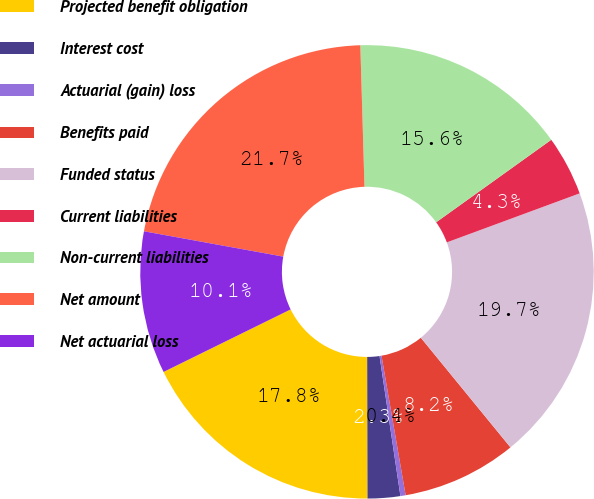Convert chart. <chart><loc_0><loc_0><loc_500><loc_500><pie_chart><fcel>Projected benefit obligation<fcel>Interest cost<fcel>Actuarial (gain) loss<fcel>Benefits paid<fcel>Funded status<fcel>Current liabilities<fcel>Non-current liabilities<fcel>Net amount<fcel>Net actuarial loss<nl><fcel>17.76%<fcel>2.32%<fcel>0.37%<fcel>8.18%<fcel>19.72%<fcel>4.27%<fcel>15.57%<fcel>21.67%<fcel>10.14%<nl></chart> 